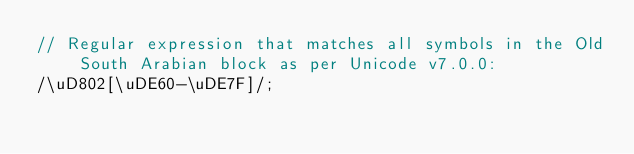Convert code to text. <code><loc_0><loc_0><loc_500><loc_500><_JavaScript_>// Regular expression that matches all symbols in the Old South Arabian block as per Unicode v7.0.0:
/\uD802[\uDE60-\uDE7F]/;</code> 